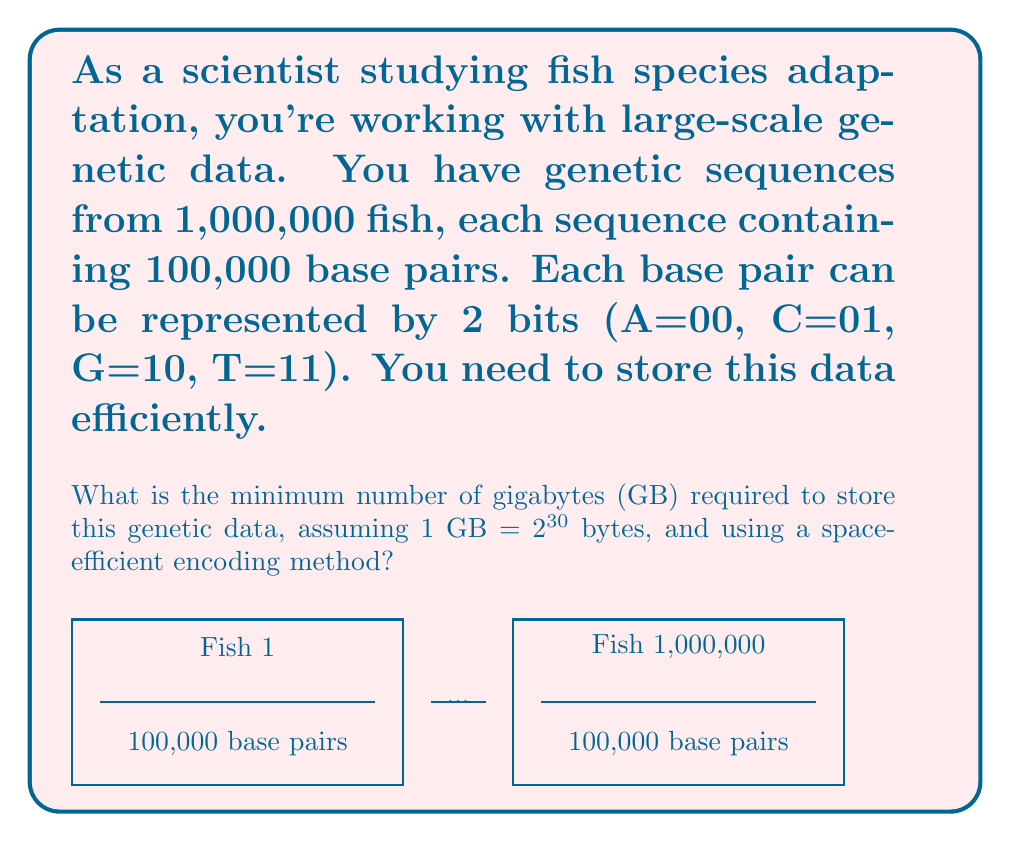Show me your answer to this math problem. Let's approach this step-by-step:

1) First, calculate the total number of base pairs:
   $1,000,000 \text{ fish} \times 100,000 \text{ base pairs} = 100,000,000,000 \text{ base pairs}$

2) Each base pair can be represented by 2 bits. So, the total number of bits required:
   $100,000,000,000 \text{ base pairs} \times 2 \text{ bits} = 200,000,000,000 \text{ bits}$

3) Convert bits to bytes (8 bits = 1 byte):
   $200,000,000,000 \text{ bits} \div 8 = 25,000,000,000 \text{ bytes}$

4) Convert bytes to gigabytes:
   $25,000,000,000 \text{ bytes} \div 2^{30} \text{ bytes/GB} = \frac{25,000,000,000}{1,073,741,824} \text{ GB}$

5) Perform the division:
   $\frac{25,000,000,000}{1,073,741,824} \approx 23.2830 \text{ GB}$

6) Round up to the nearest whole number of gigabytes, as we can't have a fraction of a gigabyte in storage:
   $24 \text{ GB}$

Therefore, the minimum number of gigabytes required to store this genetic data is 24 GB.
Answer: 24 GB 